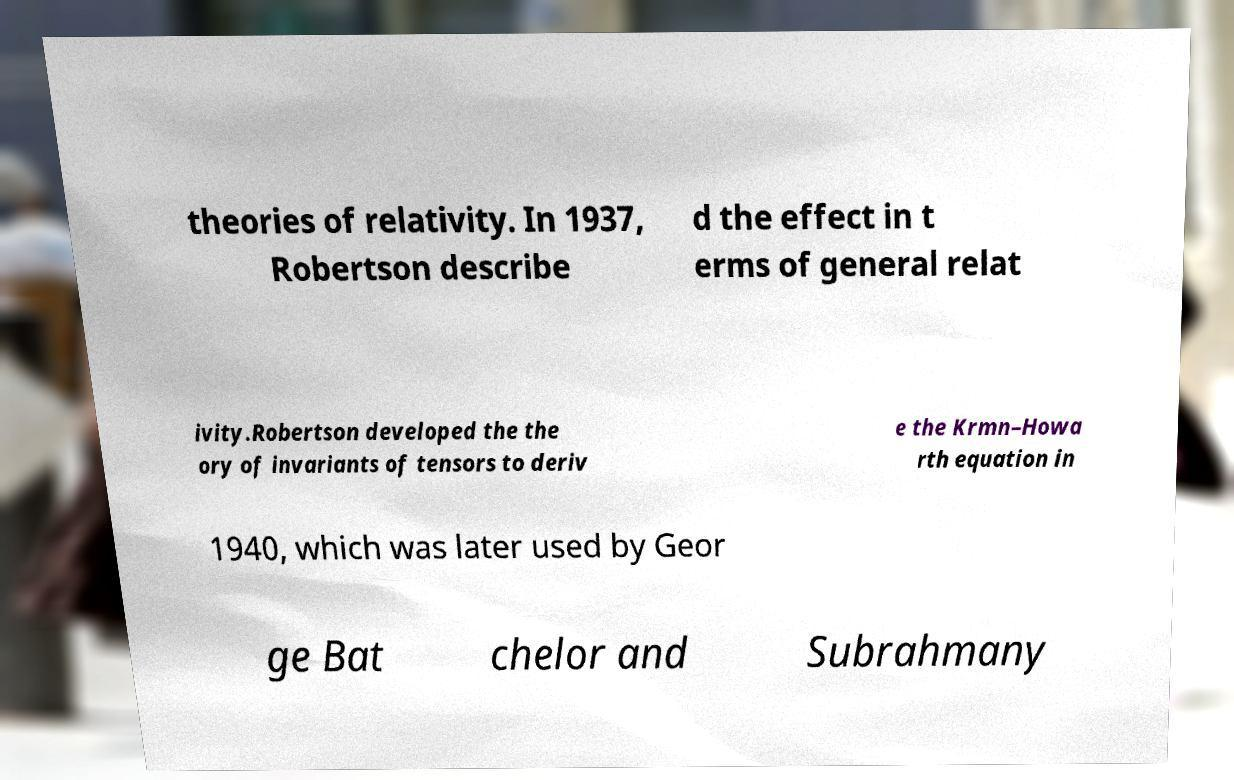Please read and relay the text visible in this image. What does it say? theories of relativity. In 1937, Robertson describe d the effect in t erms of general relat ivity.Robertson developed the the ory of invariants of tensors to deriv e the Krmn–Howa rth equation in 1940, which was later used by Geor ge Bat chelor and Subrahmany 